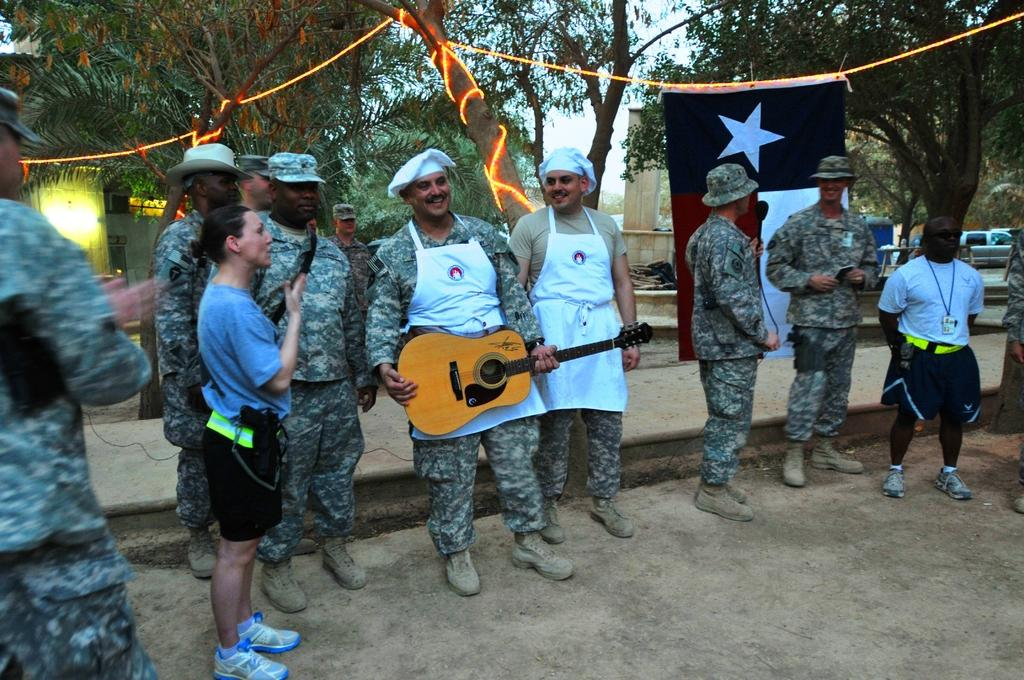What are the people in the image doing? The people in the image are standing. What is the man holding in the image? The man is holding a guitar. What can be seen in the background of the image? In the background of the image, there is a flag, trees, lights, vehicles, and the sky. How many clovers can be seen growing on the street in the image? There are no clovers or streets present in the image. What news story is being discussed by the people in the image? There is no indication of a news story being discussed in the image. 